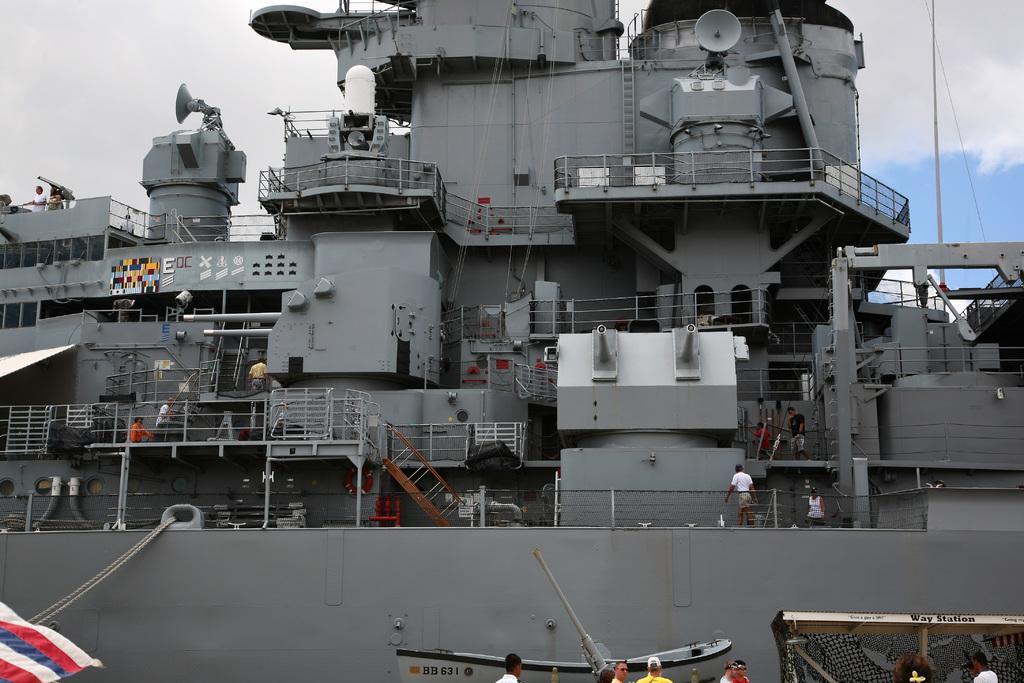Can you describe this image briefly? There is gray color ship. There are persons walking on the floor, there are persons standing on the floor. On the left side, there is flag, there are persons in different color dresses, standing near the ship. In the background, there are clouds in the blue sky. 